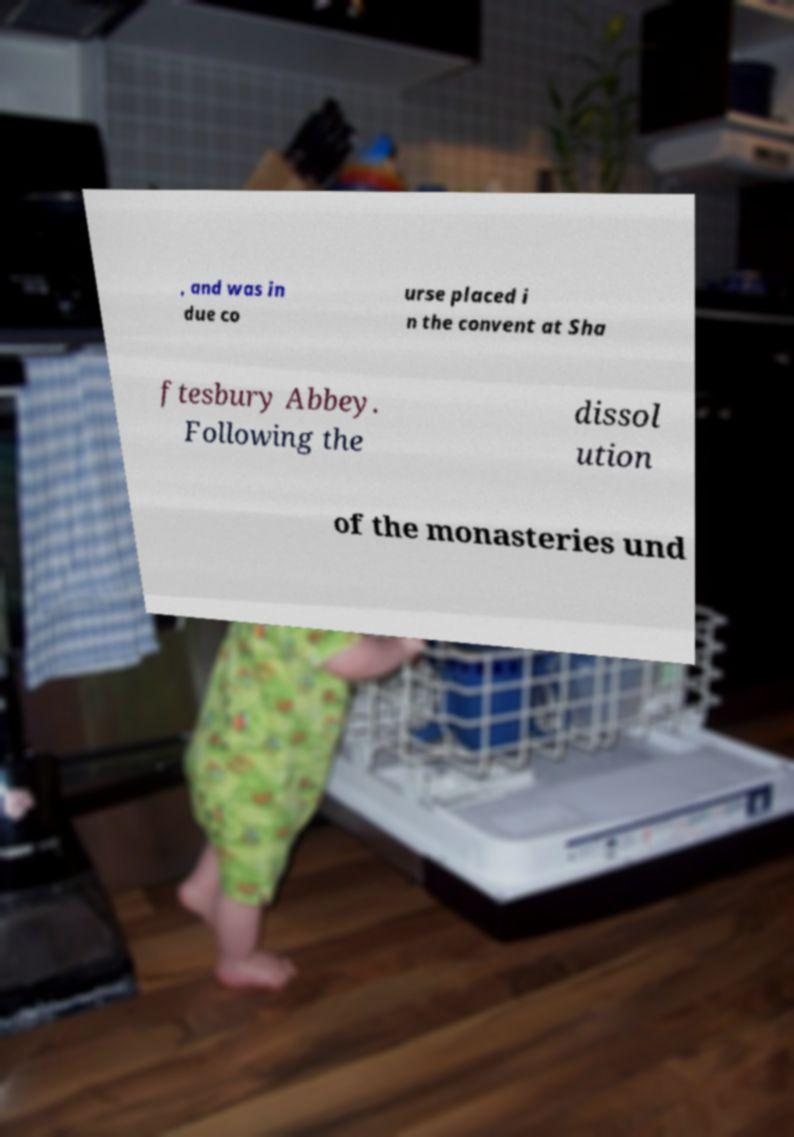What messages or text are displayed in this image? I need them in a readable, typed format. , and was in due co urse placed i n the convent at Sha ftesbury Abbey. Following the dissol ution of the monasteries und 